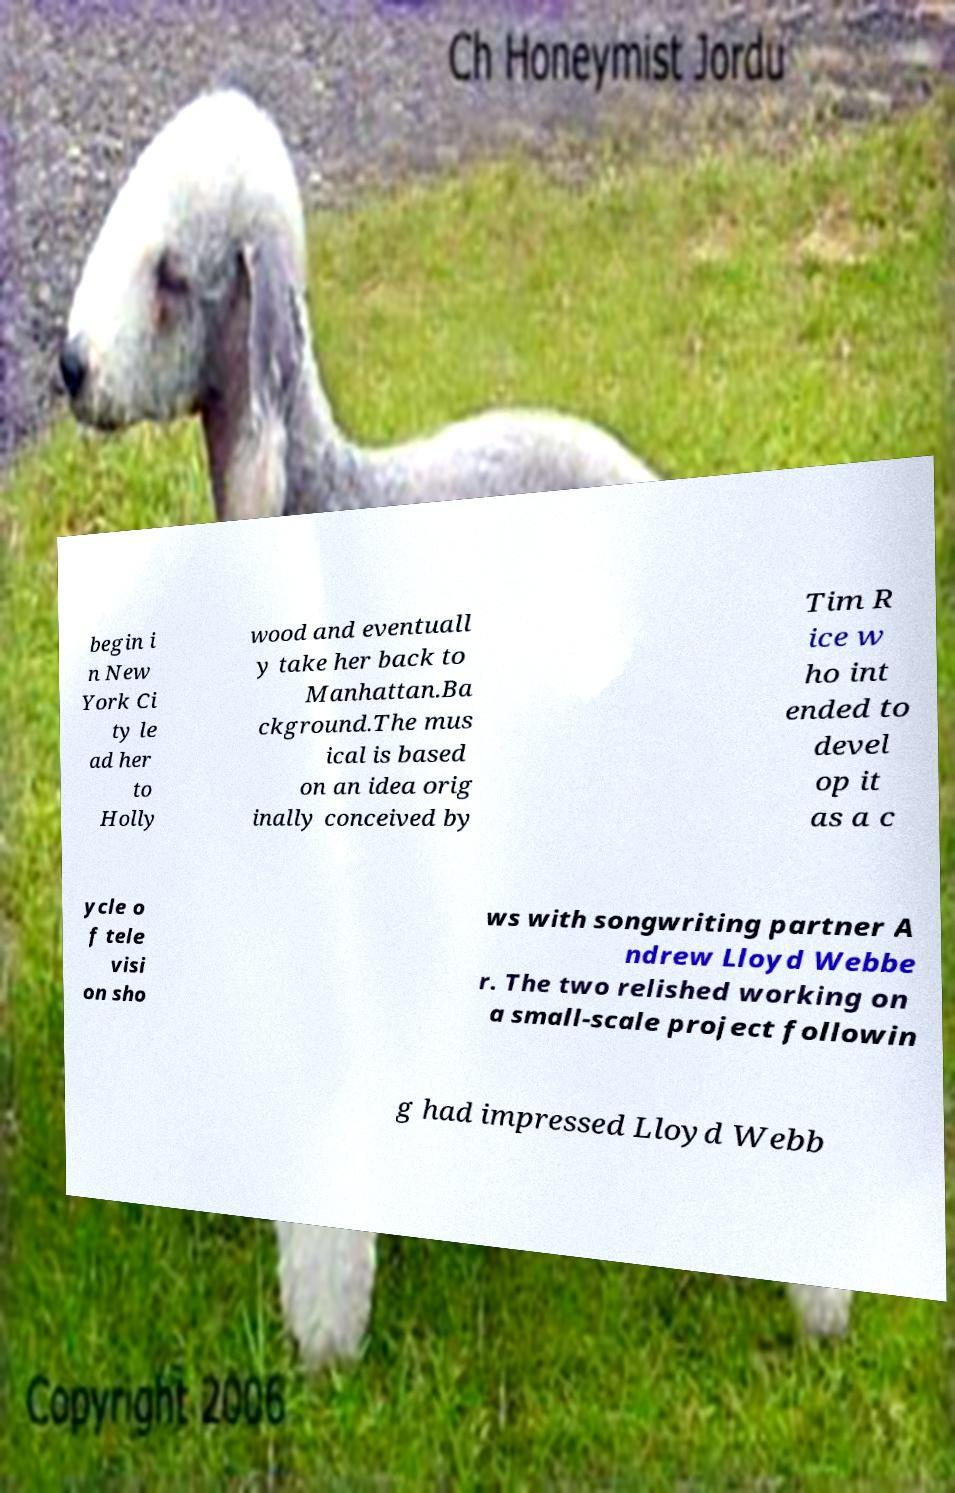There's text embedded in this image that I need extracted. Can you transcribe it verbatim? begin i n New York Ci ty le ad her to Holly wood and eventuall y take her back to Manhattan.Ba ckground.The mus ical is based on an idea orig inally conceived by Tim R ice w ho int ended to devel op it as a c ycle o f tele visi on sho ws with songwriting partner A ndrew Lloyd Webbe r. The two relished working on a small-scale project followin g had impressed Lloyd Webb 